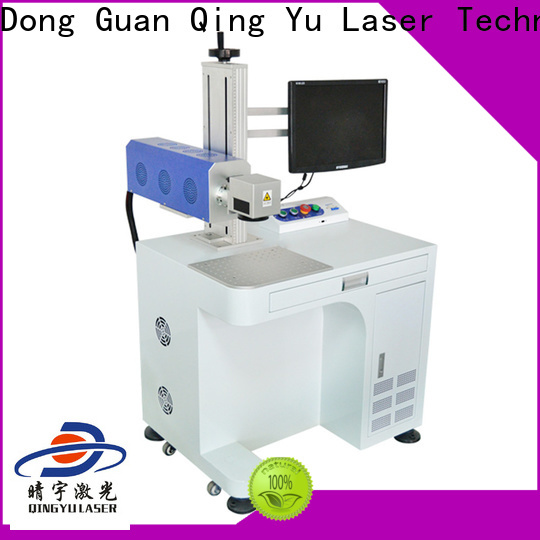Given its capabilities, how might this laser engraving machine be adapted for small business use? This laser engraving machine could be highly valuable for small businesses due to its versatility and precision. Custom jewelry manufacturers could use it to engrave intricate designs and personalized text, enhancing their product offerings. In a small-scale manufacturing setup, it could be employed for creating bespoke items such as custom phone cases, accessories, or branded promotional products. Craft businesses could leverage its capabilities to produce fine, detailed engravings on handmade goods, adding a touch of professionalism to artisanal products. Its relatively compact size and mobility also mean it can be accommodated in smaller workspaces, making it a practical choice for entrepreneurs looking to offer high-quality, customized products to their customers. 